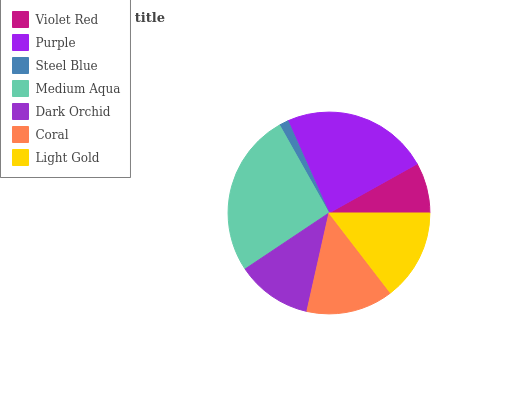Is Steel Blue the minimum?
Answer yes or no. Yes. Is Medium Aqua the maximum?
Answer yes or no. Yes. Is Purple the minimum?
Answer yes or no. No. Is Purple the maximum?
Answer yes or no. No. Is Purple greater than Violet Red?
Answer yes or no. Yes. Is Violet Red less than Purple?
Answer yes or no. Yes. Is Violet Red greater than Purple?
Answer yes or no. No. Is Purple less than Violet Red?
Answer yes or no. No. Is Coral the high median?
Answer yes or no. Yes. Is Coral the low median?
Answer yes or no. Yes. Is Violet Red the high median?
Answer yes or no. No. Is Light Gold the low median?
Answer yes or no. No. 